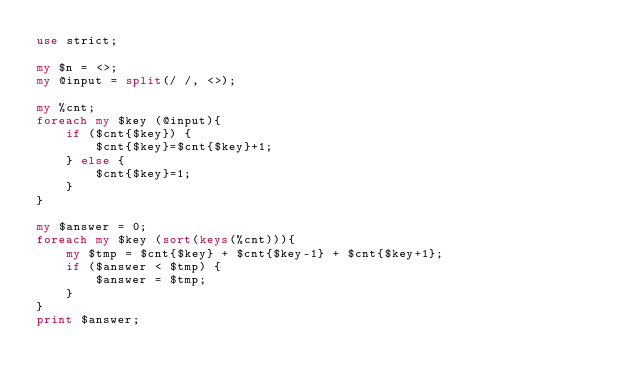<code> <loc_0><loc_0><loc_500><loc_500><_Perl_>use strict;

my $n = <>;
my @input = split(/ /, <>);

my %cnt;
foreach my $key (@input){
    if ($cnt{$key}) {
        $cnt{$key}=$cnt{$key}+1;
    } else {
        $cnt{$key}=1;
    }
}

my $answer = 0;
foreach my $key (sort(keys(%cnt))){
    my $tmp = $cnt{$key} + $cnt{$key-1} + $cnt{$key+1};
    if ($answer < $tmp) {
        $answer = $tmp;
    }
}
print $answer;</code> 